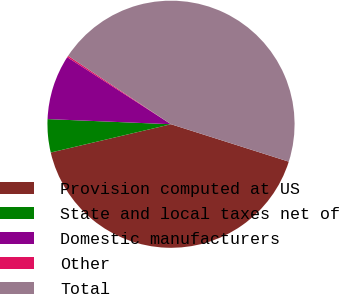Convert chart. <chart><loc_0><loc_0><loc_500><loc_500><pie_chart><fcel>Provision computed at US<fcel>State and local taxes net of<fcel>Domestic manufacturers<fcel>Other<fcel>Total<nl><fcel>41.43%<fcel>4.34%<fcel>8.47%<fcel>0.2%<fcel>45.56%<nl></chart> 